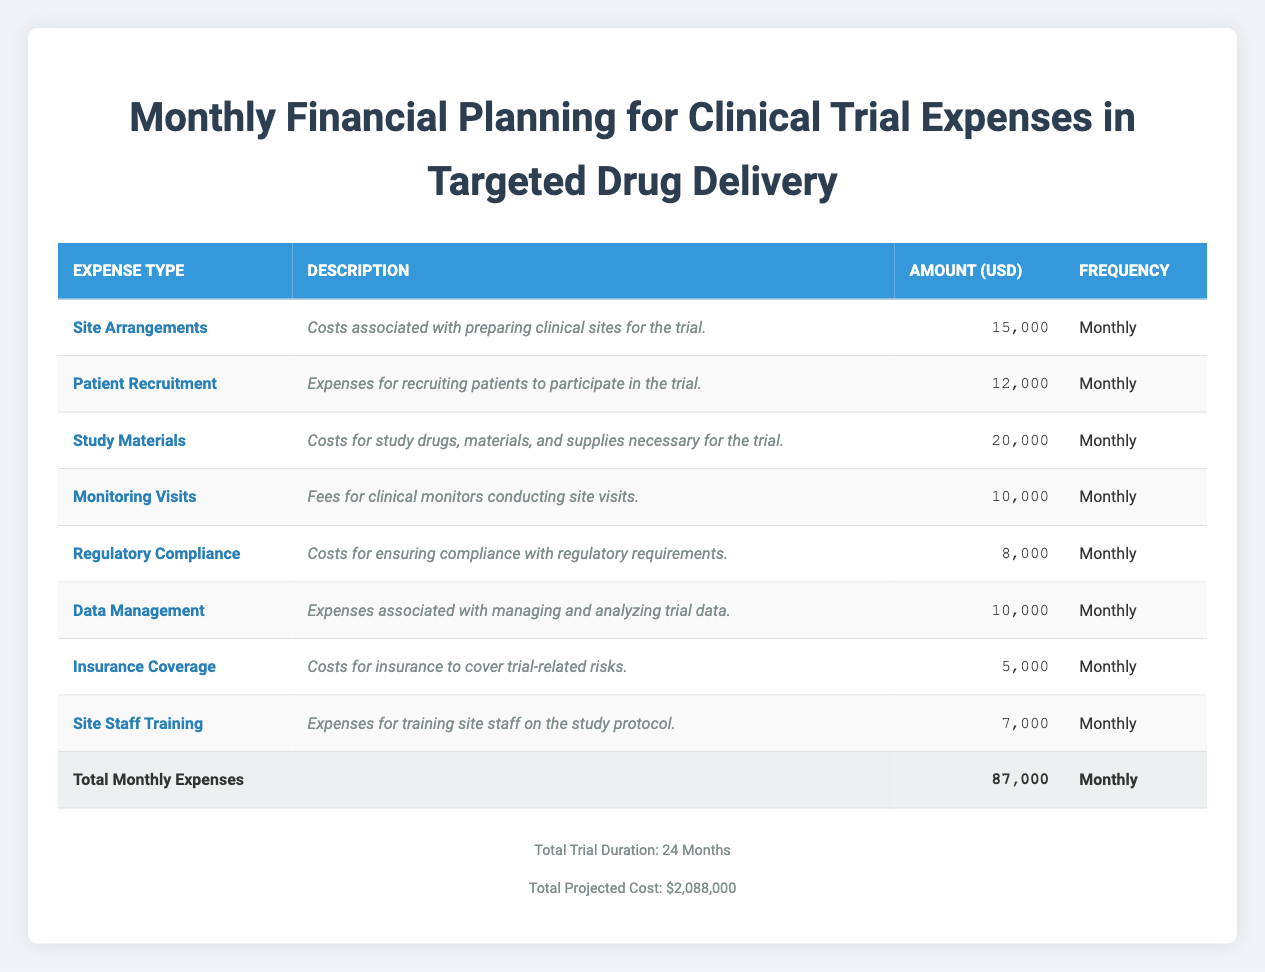What is the total monthly expense for the clinical trial? To find the total monthly expense, we need to add all the monthly amounts listed for each expense type. The amounts are: 15000, 12000, 20000, 10000, 8000, 10000, 5000, and 7000. Adding these together gives us: 15000 + 12000 + 20000 + 10000 + 8000 + 10000 + 5000 + 7000 = 87000.
Answer: 87000 How much is budgeted for patient recruitment each month? The table shows that the amount budgeted for patient recruitment is 12000.
Answer: 12000 Is the total projected cost for the trial more than 2 million USD? The total projected cost is listed as 2,088,000, which is greater than 2 million.
Answer: Yes What is the average monthly expense on site arrangements and study materials? To find the average, first identify the monthly expenses for site arrangements (15000) and study materials (20000). Summing these gives: 15000 + 20000 = 35000. Dividing this by 2 will give us the average: 35000 / 2 = 17500.
Answer: 17500 What percentage of the total budget is spent on data management? The monthly expense for data management is 10000, which amounts to a total of 10000 * 24 = 240000 over the duration of the trial. The total projected cost is 2,088,000, so the percentage spent is (240000 / 2088000) * 100 = 11.5%.
Answer: 11.5% Are insurance coverage and monitoring visits the least expensive monthly expenses? The monthly expenses for insurance coverage and monitoring visits are 5000 and 10000 respectively. Since 5000 is lower than all other expenses, insurance coverage is indeed the least expensive. However, monitoring visits (10000) are not the least expensive as there is another expense (insurance coverage) lower than that.
Answer: No How much would it cost to conduct the entire clinical trial without regulatory compliance expenses? The regulatory compliance expense is 8000, and since the trial lasts 24 months, the total compliance cost would be: 8000 * 24 = 192000. The total projected cost is 2088000. Subtracting the compliance cost: 2088000 - 192000 = 1896000. Thus, the entire trial without regulatory compliance expenses would cost 1896000.
Answer: 1896000 Which expense type has the highest monthly expense, and what is that amount? From the table, the highest monthly expense is for study materials at 20000.
Answer: 20000 What is the total monthly expense for training site staff relative to the overall budget? The monthly expense for training site staff is 7000. Over 24 months, the total would be 7000 * 24 = 168000. The total projected cost is 2,088,000. To find the ratio of the training cost to the budget: (168000 / 2088000) * 100 = 8%.
Answer: 8% 